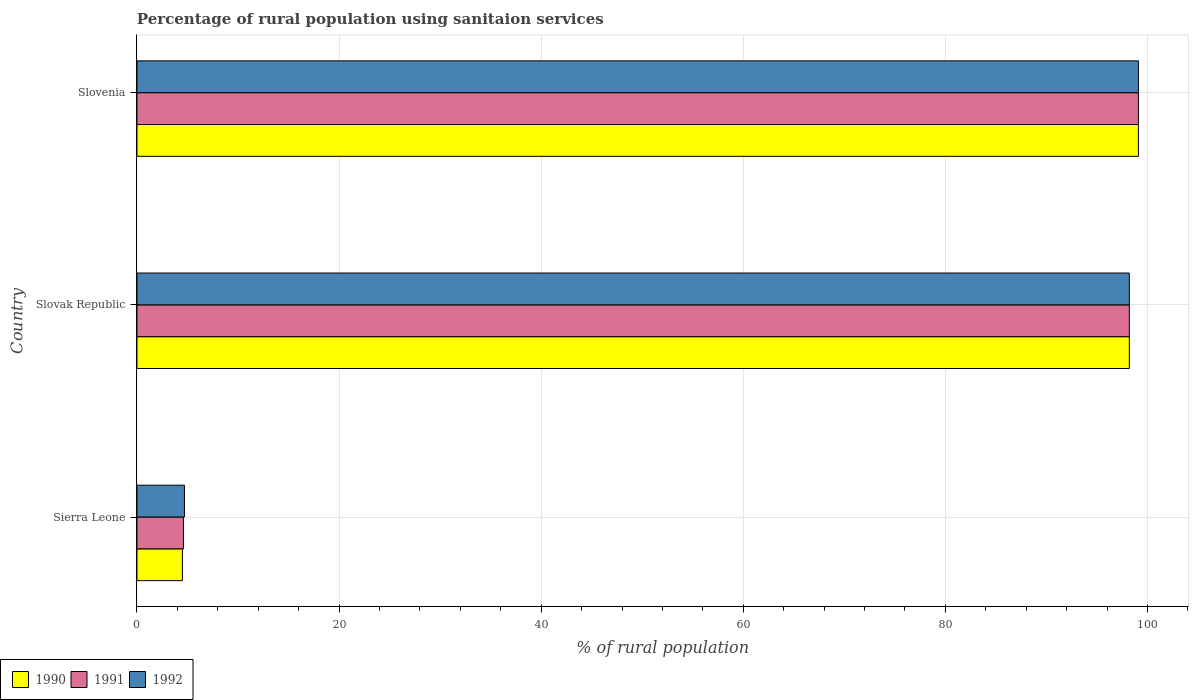How many different coloured bars are there?
Your answer should be compact. 3. Are the number of bars per tick equal to the number of legend labels?
Your answer should be compact. Yes. Are the number of bars on each tick of the Y-axis equal?
Offer a terse response. Yes. How many bars are there on the 3rd tick from the bottom?
Your response must be concise. 3. What is the label of the 3rd group of bars from the top?
Make the answer very short. Sierra Leone. In how many cases, is the number of bars for a given country not equal to the number of legend labels?
Give a very brief answer. 0. What is the percentage of rural population using sanitaion services in 1992 in Slovak Republic?
Give a very brief answer. 98.2. Across all countries, what is the maximum percentage of rural population using sanitaion services in 1990?
Your answer should be compact. 99.1. In which country was the percentage of rural population using sanitaion services in 1992 maximum?
Your answer should be very brief. Slovenia. In which country was the percentage of rural population using sanitaion services in 1992 minimum?
Provide a short and direct response. Sierra Leone. What is the total percentage of rural population using sanitaion services in 1991 in the graph?
Make the answer very short. 201.9. What is the difference between the percentage of rural population using sanitaion services in 1990 in Sierra Leone and that in Slovak Republic?
Keep it short and to the point. -93.7. What is the difference between the percentage of rural population using sanitaion services in 1991 in Slovak Republic and the percentage of rural population using sanitaion services in 1992 in Slovenia?
Offer a very short reply. -0.9. What is the average percentage of rural population using sanitaion services in 1991 per country?
Ensure brevity in your answer.  67.3. What is the difference between the percentage of rural population using sanitaion services in 1992 and percentage of rural population using sanitaion services in 1991 in Slovenia?
Your answer should be compact. 0. In how many countries, is the percentage of rural population using sanitaion services in 1991 greater than 44 %?
Your answer should be very brief. 2. What is the ratio of the percentage of rural population using sanitaion services in 1992 in Sierra Leone to that in Slovenia?
Provide a short and direct response. 0.05. Is the percentage of rural population using sanitaion services in 1990 in Sierra Leone less than that in Slovak Republic?
Offer a very short reply. Yes. What is the difference between the highest and the second highest percentage of rural population using sanitaion services in 1990?
Offer a very short reply. 0.9. What is the difference between the highest and the lowest percentage of rural population using sanitaion services in 1991?
Ensure brevity in your answer.  94.5. In how many countries, is the percentage of rural population using sanitaion services in 1991 greater than the average percentage of rural population using sanitaion services in 1991 taken over all countries?
Ensure brevity in your answer.  2. What is the difference between two consecutive major ticks on the X-axis?
Your response must be concise. 20. Does the graph contain grids?
Provide a succinct answer. Yes. Where does the legend appear in the graph?
Your answer should be very brief. Bottom left. How many legend labels are there?
Offer a terse response. 3. What is the title of the graph?
Give a very brief answer. Percentage of rural population using sanitaion services. What is the label or title of the X-axis?
Offer a terse response. % of rural population. What is the label or title of the Y-axis?
Your response must be concise. Country. What is the % of rural population of 1992 in Sierra Leone?
Your response must be concise. 4.7. What is the % of rural population in 1990 in Slovak Republic?
Make the answer very short. 98.2. What is the % of rural population in 1991 in Slovak Republic?
Your answer should be very brief. 98.2. What is the % of rural population in 1992 in Slovak Republic?
Offer a very short reply. 98.2. What is the % of rural population of 1990 in Slovenia?
Your answer should be very brief. 99.1. What is the % of rural population in 1991 in Slovenia?
Your answer should be compact. 99.1. What is the % of rural population in 1992 in Slovenia?
Make the answer very short. 99.1. Across all countries, what is the maximum % of rural population in 1990?
Give a very brief answer. 99.1. Across all countries, what is the maximum % of rural population of 1991?
Provide a succinct answer. 99.1. Across all countries, what is the maximum % of rural population in 1992?
Make the answer very short. 99.1. Across all countries, what is the minimum % of rural population of 1990?
Ensure brevity in your answer.  4.5. What is the total % of rural population of 1990 in the graph?
Your answer should be compact. 201.8. What is the total % of rural population of 1991 in the graph?
Provide a short and direct response. 201.9. What is the total % of rural population of 1992 in the graph?
Ensure brevity in your answer.  202. What is the difference between the % of rural population in 1990 in Sierra Leone and that in Slovak Republic?
Your answer should be compact. -93.7. What is the difference between the % of rural population in 1991 in Sierra Leone and that in Slovak Republic?
Provide a succinct answer. -93.6. What is the difference between the % of rural population in 1992 in Sierra Leone and that in Slovak Republic?
Your answer should be very brief. -93.5. What is the difference between the % of rural population in 1990 in Sierra Leone and that in Slovenia?
Provide a short and direct response. -94.6. What is the difference between the % of rural population of 1991 in Sierra Leone and that in Slovenia?
Offer a very short reply. -94.5. What is the difference between the % of rural population of 1992 in Sierra Leone and that in Slovenia?
Provide a short and direct response. -94.4. What is the difference between the % of rural population of 1991 in Slovak Republic and that in Slovenia?
Your response must be concise. -0.9. What is the difference between the % of rural population of 1992 in Slovak Republic and that in Slovenia?
Provide a short and direct response. -0.9. What is the difference between the % of rural population of 1990 in Sierra Leone and the % of rural population of 1991 in Slovak Republic?
Keep it short and to the point. -93.7. What is the difference between the % of rural population in 1990 in Sierra Leone and the % of rural population in 1992 in Slovak Republic?
Offer a very short reply. -93.7. What is the difference between the % of rural population of 1991 in Sierra Leone and the % of rural population of 1992 in Slovak Republic?
Your response must be concise. -93.6. What is the difference between the % of rural population in 1990 in Sierra Leone and the % of rural population in 1991 in Slovenia?
Provide a short and direct response. -94.6. What is the difference between the % of rural population of 1990 in Sierra Leone and the % of rural population of 1992 in Slovenia?
Make the answer very short. -94.6. What is the difference between the % of rural population in 1991 in Sierra Leone and the % of rural population in 1992 in Slovenia?
Your response must be concise. -94.5. What is the difference between the % of rural population of 1990 in Slovak Republic and the % of rural population of 1991 in Slovenia?
Provide a succinct answer. -0.9. What is the difference between the % of rural population in 1990 in Slovak Republic and the % of rural population in 1992 in Slovenia?
Make the answer very short. -0.9. What is the average % of rural population in 1990 per country?
Ensure brevity in your answer.  67.27. What is the average % of rural population in 1991 per country?
Make the answer very short. 67.3. What is the average % of rural population of 1992 per country?
Ensure brevity in your answer.  67.33. What is the difference between the % of rural population in 1990 and % of rural population in 1991 in Sierra Leone?
Make the answer very short. -0.1. What is the difference between the % of rural population of 1990 and % of rural population of 1992 in Sierra Leone?
Offer a very short reply. -0.2. What is the difference between the % of rural population of 1991 and % of rural population of 1992 in Sierra Leone?
Offer a very short reply. -0.1. What is the difference between the % of rural population in 1990 and % of rural population in 1991 in Slovak Republic?
Keep it short and to the point. 0. What is the difference between the % of rural population of 1990 and % of rural population of 1992 in Slovak Republic?
Offer a terse response. 0. What is the difference between the % of rural population of 1990 and % of rural population of 1991 in Slovenia?
Provide a short and direct response. 0. What is the ratio of the % of rural population in 1990 in Sierra Leone to that in Slovak Republic?
Your answer should be very brief. 0.05. What is the ratio of the % of rural population of 1991 in Sierra Leone to that in Slovak Republic?
Give a very brief answer. 0.05. What is the ratio of the % of rural population of 1992 in Sierra Leone to that in Slovak Republic?
Make the answer very short. 0.05. What is the ratio of the % of rural population in 1990 in Sierra Leone to that in Slovenia?
Your response must be concise. 0.05. What is the ratio of the % of rural population of 1991 in Sierra Leone to that in Slovenia?
Offer a terse response. 0.05. What is the ratio of the % of rural population of 1992 in Sierra Leone to that in Slovenia?
Provide a succinct answer. 0.05. What is the ratio of the % of rural population of 1990 in Slovak Republic to that in Slovenia?
Offer a very short reply. 0.99. What is the ratio of the % of rural population in 1991 in Slovak Republic to that in Slovenia?
Ensure brevity in your answer.  0.99. What is the ratio of the % of rural population of 1992 in Slovak Republic to that in Slovenia?
Give a very brief answer. 0.99. What is the difference between the highest and the second highest % of rural population in 1990?
Your response must be concise. 0.9. What is the difference between the highest and the second highest % of rural population in 1991?
Provide a short and direct response. 0.9. What is the difference between the highest and the lowest % of rural population in 1990?
Give a very brief answer. 94.6. What is the difference between the highest and the lowest % of rural population in 1991?
Provide a succinct answer. 94.5. What is the difference between the highest and the lowest % of rural population in 1992?
Your answer should be compact. 94.4. 